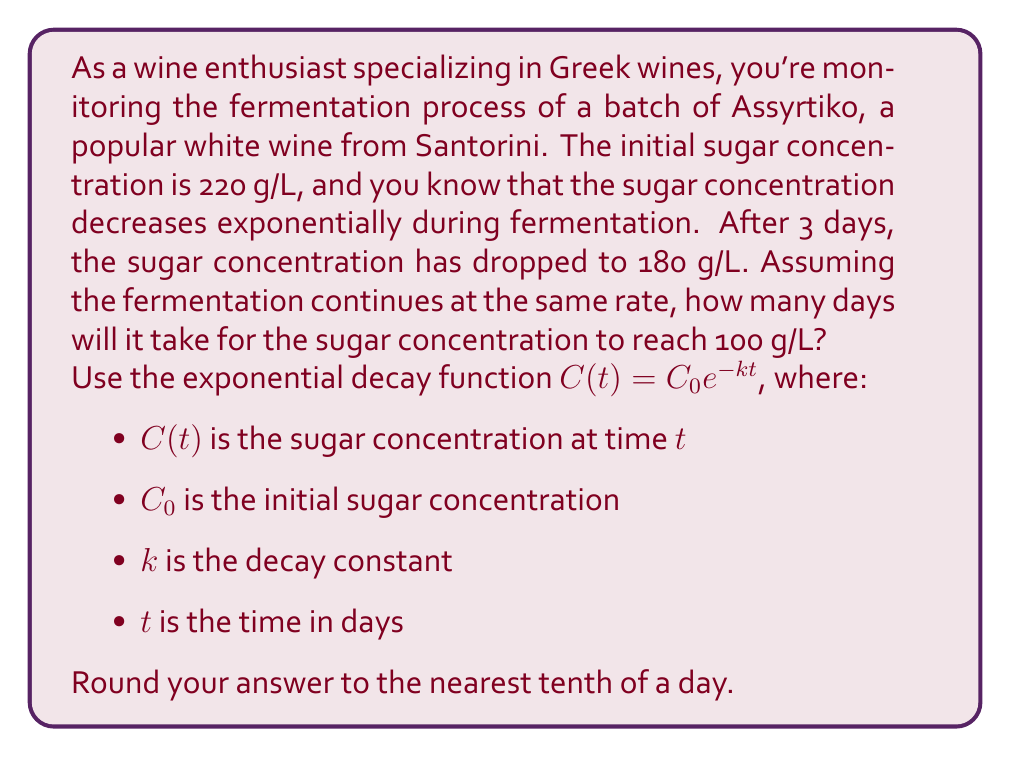What is the answer to this math problem? Let's approach this step-by-step:

1) We're given the exponential decay function: $C(t) = C_0 e^{-kt}$

2) We know:
   $C_0 = 220$ g/L (initial concentration)
   $C(3) = 180$ g/L (concentration after 3 days)
   We need to find $t$ when $C(t) = 100$ g/L

3) First, let's find the decay constant $k$ using the given information:

   $180 = 220 e^{-3k}$
   
   $\frac{180}{220} = e^{-3k}$
   
   $\ln(\frac{180}{220}) = -3k$
   
   $k = -\frac{1}{3}\ln(\frac{180}{220}) \approx 0.0667$

4) Now that we have $k$, we can use the original equation to find $t$ when $C(t) = 100$:

   $100 = 220 e^{-0.0667t}$
   
   $\frac{100}{220} = e^{-0.0667t}$
   
   $\ln(\frac{100}{220}) = -0.0667t$
   
   $t = -\frac{1}{0.0667}\ln(\frac{100}{220}) \approx 12.3$ days

5) Rounding to the nearest tenth of a day, we get 12.3 days.
Answer: 12.3 days 